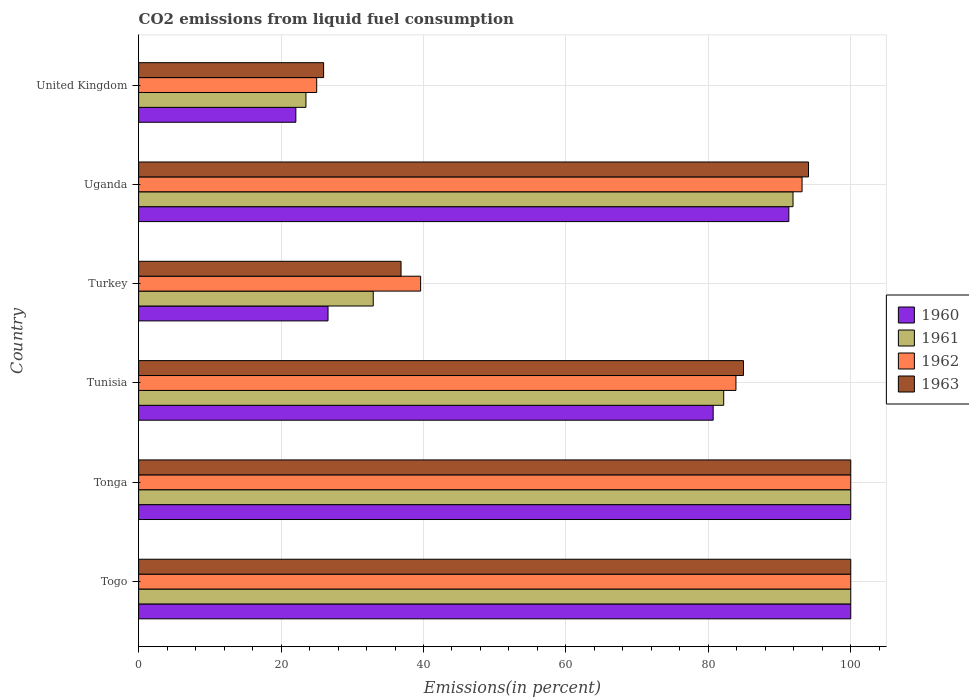How many groups of bars are there?
Give a very brief answer. 6. Are the number of bars on each tick of the Y-axis equal?
Provide a short and direct response. Yes. What is the label of the 5th group of bars from the top?
Provide a short and direct response. Tonga. What is the total CO2 emitted in 1963 in Turkey?
Keep it short and to the point. 36.85. Across all countries, what is the minimum total CO2 emitted in 1960?
Offer a very short reply. 22.08. In which country was the total CO2 emitted in 1962 maximum?
Your answer should be compact. Togo. What is the total total CO2 emitted in 1963 in the graph?
Give a very brief answer. 441.83. What is the difference between the total CO2 emitted in 1961 in Togo and that in Tonga?
Your response must be concise. 0. What is the difference between the total CO2 emitted in 1960 in Tonga and the total CO2 emitted in 1963 in United Kingdom?
Make the answer very short. 74.02. What is the average total CO2 emitted in 1962 per country?
Your answer should be compact. 73.61. What is the difference between the total CO2 emitted in 1960 and total CO2 emitted in 1963 in Tunisia?
Keep it short and to the point. -4.25. What is the ratio of the total CO2 emitted in 1961 in Togo to that in Turkey?
Give a very brief answer. 3.04. Is the difference between the total CO2 emitted in 1960 in Turkey and United Kingdom greater than the difference between the total CO2 emitted in 1963 in Turkey and United Kingdom?
Keep it short and to the point. No. What is the difference between the highest and the lowest total CO2 emitted in 1962?
Provide a short and direct response. 74.99. Is the sum of the total CO2 emitted in 1963 in Tunisia and United Kingdom greater than the maximum total CO2 emitted in 1962 across all countries?
Offer a terse response. Yes. What does the 4th bar from the top in Turkey represents?
Provide a succinct answer. 1960. What does the 3rd bar from the bottom in Uganda represents?
Offer a terse response. 1962. How many bars are there?
Give a very brief answer. 24. Are all the bars in the graph horizontal?
Provide a succinct answer. Yes. How many countries are there in the graph?
Provide a succinct answer. 6. Are the values on the major ticks of X-axis written in scientific E-notation?
Your response must be concise. No. Does the graph contain any zero values?
Offer a terse response. No. How are the legend labels stacked?
Give a very brief answer. Vertical. What is the title of the graph?
Offer a very short reply. CO2 emissions from liquid fuel consumption. Does "1965" appear as one of the legend labels in the graph?
Offer a terse response. No. What is the label or title of the X-axis?
Provide a short and direct response. Emissions(in percent). What is the Emissions(in percent) of 1960 in Togo?
Your answer should be compact. 100. What is the Emissions(in percent) in 1961 in Togo?
Provide a short and direct response. 100. What is the Emissions(in percent) of 1963 in Togo?
Keep it short and to the point. 100. What is the Emissions(in percent) of 1961 in Tonga?
Make the answer very short. 100. What is the Emissions(in percent) of 1963 in Tonga?
Keep it short and to the point. 100. What is the Emissions(in percent) of 1960 in Tunisia?
Your response must be concise. 80.68. What is the Emissions(in percent) in 1961 in Tunisia?
Provide a succinct answer. 82.16. What is the Emissions(in percent) in 1962 in Tunisia?
Your answer should be very brief. 83.88. What is the Emissions(in percent) of 1963 in Tunisia?
Keep it short and to the point. 84.93. What is the Emissions(in percent) in 1960 in Turkey?
Make the answer very short. 26.6. What is the Emissions(in percent) of 1961 in Turkey?
Ensure brevity in your answer.  32.95. What is the Emissions(in percent) in 1962 in Turkey?
Offer a very short reply. 39.6. What is the Emissions(in percent) of 1963 in Turkey?
Make the answer very short. 36.85. What is the Emissions(in percent) in 1960 in Uganda?
Offer a terse response. 91.3. What is the Emissions(in percent) of 1961 in Uganda?
Your response must be concise. 91.89. What is the Emissions(in percent) of 1962 in Uganda?
Provide a succinct answer. 93.16. What is the Emissions(in percent) in 1963 in Uganda?
Keep it short and to the point. 94.07. What is the Emissions(in percent) in 1960 in United Kingdom?
Provide a succinct answer. 22.08. What is the Emissions(in percent) in 1961 in United Kingdom?
Your answer should be compact. 23.5. What is the Emissions(in percent) of 1962 in United Kingdom?
Provide a short and direct response. 25.01. What is the Emissions(in percent) of 1963 in United Kingdom?
Offer a very short reply. 25.98. Across all countries, what is the maximum Emissions(in percent) of 1960?
Keep it short and to the point. 100. Across all countries, what is the maximum Emissions(in percent) in 1961?
Make the answer very short. 100. Across all countries, what is the maximum Emissions(in percent) of 1962?
Your answer should be very brief. 100. Across all countries, what is the minimum Emissions(in percent) in 1960?
Ensure brevity in your answer.  22.08. Across all countries, what is the minimum Emissions(in percent) of 1961?
Your answer should be compact. 23.5. Across all countries, what is the minimum Emissions(in percent) of 1962?
Offer a terse response. 25.01. Across all countries, what is the minimum Emissions(in percent) of 1963?
Ensure brevity in your answer.  25.98. What is the total Emissions(in percent) of 1960 in the graph?
Give a very brief answer. 420.66. What is the total Emissions(in percent) in 1961 in the graph?
Provide a succinct answer. 430.49. What is the total Emissions(in percent) in 1962 in the graph?
Keep it short and to the point. 441.64. What is the total Emissions(in percent) in 1963 in the graph?
Keep it short and to the point. 441.83. What is the difference between the Emissions(in percent) of 1960 in Togo and that in Tonga?
Provide a succinct answer. 0. What is the difference between the Emissions(in percent) of 1961 in Togo and that in Tonga?
Provide a succinct answer. 0. What is the difference between the Emissions(in percent) in 1962 in Togo and that in Tonga?
Give a very brief answer. 0. What is the difference between the Emissions(in percent) in 1963 in Togo and that in Tonga?
Offer a very short reply. 0. What is the difference between the Emissions(in percent) in 1960 in Togo and that in Tunisia?
Ensure brevity in your answer.  19.32. What is the difference between the Emissions(in percent) in 1961 in Togo and that in Tunisia?
Offer a very short reply. 17.84. What is the difference between the Emissions(in percent) of 1962 in Togo and that in Tunisia?
Make the answer very short. 16.12. What is the difference between the Emissions(in percent) in 1963 in Togo and that in Tunisia?
Keep it short and to the point. 15.07. What is the difference between the Emissions(in percent) in 1960 in Togo and that in Turkey?
Provide a short and direct response. 73.4. What is the difference between the Emissions(in percent) in 1961 in Togo and that in Turkey?
Your response must be concise. 67.05. What is the difference between the Emissions(in percent) in 1962 in Togo and that in Turkey?
Your response must be concise. 60.4. What is the difference between the Emissions(in percent) of 1963 in Togo and that in Turkey?
Your answer should be compact. 63.15. What is the difference between the Emissions(in percent) in 1960 in Togo and that in Uganda?
Offer a terse response. 8.7. What is the difference between the Emissions(in percent) of 1961 in Togo and that in Uganda?
Make the answer very short. 8.11. What is the difference between the Emissions(in percent) in 1962 in Togo and that in Uganda?
Offer a very short reply. 6.84. What is the difference between the Emissions(in percent) of 1963 in Togo and that in Uganda?
Offer a very short reply. 5.93. What is the difference between the Emissions(in percent) in 1960 in Togo and that in United Kingdom?
Offer a terse response. 77.92. What is the difference between the Emissions(in percent) in 1961 in Togo and that in United Kingdom?
Ensure brevity in your answer.  76.5. What is the difference between the Emissions(in percent) in 1962 in Togo and that in United Kingdom?
Offer a terse response. 74.99. What is the difference between the Emissions(in percent) of 1963 in Togo and that in United Kingdom?
Provide a short and direct response. 74.02. What is the difference between the Emissions(in percent) in 1960 in Tonga and that in Tunisia?
Your response must be concise. 19.32. What is the difference between the Emissions(in percent) in 1961 in Tonga and that in Tunisia?
Your answer should be compact. 17.84. What is the difference between the Emissions(in percent) of 1962 in Tonga and that in Tunisia?
Your answer should be compact. 16.12. What is the difference between the Emissions(in percent) in 1963 in Tonga and that in Tunisia?
Your response must be concise. 15.07. What is the difference between the Emissions(in percent) in 1960 in Tonga and that in Turkey?
Your response must be concise. 73.4. What is the difference between the Emissions(in percent) of 1961 in Tonga and that in Turkey?
Give a very brief answer. 67.05. What is the difference between the Emissions(in percent) of 1962 in Tonga and that in Turkey?
Provide a short and direct response. 60.4. What is the difference between the Emissions(in percent) of 1963 in Tonga and that in Turkey?
Offer a very short reply. 63.15. What is the difference between the Emissions(in percent) of 1960 in Tonga and that in Uganda?
Your answer should be very brief. 8.7. What is the difference between the Emissions(in percent) of 1961 in Tonga and that in Uganda?
Your response must be concise. 8.11. What is the difference between the Emissions(in percent) in 1962 in Tonga and that in Uganda?
Provide a short and direct response. 6.84. What is the difference between the Emissions(in percent) in 1963 in Tonga and that in Uganda?
Give a very brief answer. 5.93. What is the difference between the Emissions(in percent) of 1960 in Tonga and that in United Kingdom?
Make the answer very short. 77.92. What is the difference between the Emissions(in percent) of 1961 in Tonga and that in United Kingdom?
Make the answer very short. 76.5. What is the difference between the Emissions(in percent) of 1962 in Tonga and that in United Kingdom?
Provide a succinct answer. 74.99. What is the difference between the Emissions(in percent) in 1963 in Tonga and that in United Kingdom?
Offer a very short reply. 74.02. What is the difference between the Emissions(in percent) in 1960 in Tunisia and that in Turkey?
Keep it short and to the point. 54.08. What is the difference between the Emissions(in percent) of 1961 in Tunisia and that in Turkey?
Ensure brevity in your answer.  49.21. What is the difference between the Emissions(in percent) in 1962 in Tunisia and that in Turkey?
Keep it short and to the point. 44.28. What is the difference between the Emissions(in percent) of 1963 in Tunisia and that in Turkey?
Your response must be concise. 48.09. What is the difference between the Emissions(in percent) of 1960 in Tunisia and that in Uganda?
Keep it short and to the point. -10.62. What is the difference between the Emissions(in percent) in 1961 in Tunisia and that in Uganda?
Offer a terse response. -9.73. What is the difference between the Emissions(in percent) of 1962 in Tunisia and that in Uganda?
Your answer should be very brief. -9.28. What is the difference between the Emissions(in percent) of 1963 in Tunisia and that in Uganda?
Make the answer very short. -9.13. What is the difference between the Emissions(in percent) of 1960 in Tunisia and that in United Kingdom?
Your answer should be compact. 58.6. What is the difference between the Emissions(in percent) of 1961 in Tunisia and that in United Kingdom?
Offer a very short reply. 58.66. What is the difference between the Emissions(in percent) of 1962 in Tunisia and that in United Kingdom?
Make the answer very short. 58.87. What is the difference between the Emissions(in percent) of 1963 in Tunisia and that in United Kingdom?
Offer a terse response. 58.96. What is the difference between the Emissions(in percent) of 1960 in Turkey and that in Uganda?
Make the answer very short. -64.71. What is the difference between the Emissions(in percent) in 1961 in Turkey and that in Uganda?
Ensure brevity in your answer.  -58.95. What is the difference between the Emissions(in percent) of 1962 in Turkey and that in Uganda?
Your answer should be compact. -53.56. What is the difference between the Emissions(in percent) of 1963 in Turkey and that in Uganda?
Offer a very short reply. -57.22. What is the difference between the Emissions(in percent) of 1960 in Turkey and that in United Kingdom?
Your answer should be very brief. 4.52. What is the difference between the Emissions(in percent) in 1961 in Turkey and that in United Kingdom?
Your answer should be very brief. 9.45. What is the difference between the Emissions(in percent) in 1962 in Turkey and that in United Kingdom?
Keep it short and to the point. 14.59. What is the difference between the Emissions(in percent) in 1963 in Turkey and that in United Kingdom?
Keep it short and to the point. 10.87. What is the difference between the Emissions(in percent) of 1960 in Uganda and that in United Kingdom?
Your answer should be very brief. 69.23. What is the difference between the Emissions(in percent) of 1961 in Uganda and that in United Kingdom?
Keep it short and to the point. 68.4. What is the difference between the Emissions(in percent) of 1962 in Uganda and that in United Kingdom?
Provide a short and direct response. 68.16. What is the difference between the Emissions(in percent) of 1963 in Uganda and that in United Kingdom?
Offer a terse response. 68.09. What is the difference between the Emissions(in percent) of 1960 in Togo and the Emissions(in percent) of 1962 in Tonga?
Offer a very short reply. 0. What is the difference between the Emissions(in percent) in 1961 in Togo and the Emissions(in percent) in 1962 in Tonga?
Your answer should be compact. 0. What is the difference between the Emissions(in percent) of 1961 in Togo and the Emissions(in percent) of 1963 in Tonga?
Make the answer very short. 0. What is the difference between the Emissions(in percent) of 1962 in Togo and the Emissions(in percent) of 1963 in Tonga?
Ensure brevity in your answer.  0. What is the difference between the Emissions(in percent) of 1960 in Togo and the Emissions(in percent) of 1961 in Tunisia?
Your answer should be very brief. 17.84. What is the difference between the Emissions(in percent) in 1960 in Togo and the Emissions(in percent) in 1962 in Tunisia?
Provide a short and direct response. 16.12. What is the difference between the Emissions(in percent) of 1960 in Togo and the Emissions(in percent) of 1963 in Tunisia?
Give a very brief answer. 15.07. What is the difference between the Emissions(in percent) of 1961 in Togo and the Emissions(in percent) of 1962 in Tunisia?
Your answer should be very brief. 16.12. What is the difference between the Emissions(in percent) in 1961 in Togo and the Emissions(in percent) in 1963 in Tunisia?
Provide a short and direct response. 15.07. What is the difference between the Emissions(in percent) of 1962 in Togo and the Emissions(in percent) of 1963 in Tunisia?
Provide a succinct answer. 15.07. What is the difference between the Emissions(in percent) in 1960 in Togo and the Emissions(in percent) in 1961 in Turkey?
Keep it short and to the point. 67.05. What is the difference between the Emissions(in percent) of 1960 in Togo and the Emissions(in percent) of 1962 in Turkey?
Your response must be concise. 60.4. What is the difference between the Emissions(in percent) in 1960 in Togo and the Emissions(in percent) in 1963 in Turkey?
Provide a short and direct response. 63.15. What is the difference between the Emissions(in percent) in 1961 in Togo and the Emissions(in percent) in 1962 in Turkey?
Your answer should be very brief. 60.4. What is the difference between the Emissions(in percent) of 1961 in Togo and the Emissions(in percent) of 1963 in Turkey?
Ensure brevity in your answer.  63.15. What is the difference between the Emissions(in percent) in 1962 in Togo and the Emissions(in percent) in 1963 in Turkey?
Provide a succinct answer. 63.15. What is the difference between the Emissions(in percent) in 1960 in Togo and the Emissions(in percent) in 1961 in Uganda?
Keep it short and to the point. 8.11. What is the difference between the Emissions(in percent) in 1960 in Togo and the Emissions(in percent) in 1962 in Uganda?
Your response must be concise. 6.84. What is the difference between the Emissions(in percent) in 1960 in Togo and the Emissions(in percent) in 1963 in Uganda?
Offer a very short reply. 5.93. What is the difference between the Emissions(in percent) of 1961 in Togo and the Emissions(in percent) of 1962 in Uganda?
Offer a terse response. 6.84. What is the difference between the Emissions(in percent) of 1961 in Togo and the Emissions(in percent) of 1963 in Uganda?
Your answer should be very brief. 5.93. What is the difference between the Emissions(in percent) of 1962 in Togo and the Emissions(in percent) of 1963 in Uganda?
Ensure brevity in your answer.  5.93. What is the difference between the Emissions(in percent) of 1960 in Togo and the Emissions(in percent) of 1961 in United Kingdom?
Your answer should be compact. 76.5. What is the difference between the Emissions(in percent) in 1960 in Togo and the Emissions(in percent) in 1962 in United Kingdom?
Your answer should be compact. 74.99. What is the difference between the Emissions(in percent) in 1960 in Togo and the Emissions(in percent) in 1963 in United Kingdom?
Offer a very short reply. 74.02. What is the difference between the Emissions(in percent) of 1961 in Togo and the Emissions(in percent) of 1962 in United Kingdom?
Give a very brief answer. 74.99. What is the difference between the Emissions(in percent) in 1961 in Togo and the Emissions(in percent) in 1963 in United Kingdom?
Give a very brief answer. 74.02. What is the difference between the Emissions(in percent) of 1962 in Togo and the Emissions(in percent) of 1963 in United Kingdom?
Offer a very short reply. 74.02. What is the difference between the Emissions(in percent) of 1960 in Tonga and the Emissions(in percent) of 1961 in Tunisia?
Provide a short and direct response. 17.84. What is the difference between the Emissions(in percent) in 1960 in Tonga and the Emissions(in percent) in 1962 in Tunisia?
Keep it short and to the point. 16.12. What is the difference between the Emissions(in percent) in 1960 in Tonga and the Emissions(in percent) in 1963 in Tunisia?
Offer a very short reply. 15.07. What is the difference between the Emissions(in percent) in 1961 in Tonga and the Emissions(in percent) in 1962 in Tunisia?
Your answer should be very brief. 16.12. What is the difference between the Emissions(in percent) of 1961 in Tonga and the Emissions(in percent) of 1963 in Tunisia?
Offer a terse response. 15.07. What is the difference between the Emissions(in percent) in 1962 in Tonga and the Emissions(in percent) in 1963 in Tunisia?
Your answer should be very brief. 15.07. What is the difference between the Emissions(in percent) in 1960 in Tonga and the Emissions(in percent) in 1961 in Turkey?
Provide a succinct answer. 67.05. What is the difference between the Emissions(in percent) of 1960 in Tonga and the Emissions(in percent) of 1962 in Turkey?
Make the answer very short. 60.4. What is the difference between the Emissions(in percent) of 1960 in Tonga and the Emissions(in percent) of 1963 in Turkey?
Offer a terse response. 63.15. What is the difference between the Emissions(in percent) of 1961 in Tonga and the Emissions(in percent) of 1962 in Turkey?
Your response must be concise. 60.4. What is the difference between the Emissions(in percent) in 1961 in Tonga and the Emissions(in percent) in 1963 in Turkey?
Ensure brevity in your answer.  63.15. What is the difference between the Emissions(in percent) of 1962 in Tonga and the Emissions(in percent) of 1963 in Turkey?
Provide a short and direct response. 63.15. What is the difference between the Emissions(in percent) in 1960 in Tonga and the Emissions(in percent) in 1961 in Uganda?
Offer a very short reply. 8.11. What is the difference between the Emissions(in percent) in 1960 in Tonga and the Emissions(in percent) in 1962 in Uganda?
Your answer should be compact. 6.84. What is the difference between the Emissions(in percent) in 1960 in Tonga and the Emissions(in percent) in 1963 in Uganda?
Offer a terse response. 5.93. What is the difference between the Emissions(in percent) in 1961 in Tonga and the Emissions(in percent) in 1962 in Uganda?
Ensure brevity in your answer.  6.84. What is the difference between the Emissions(in percent) in 1961 in Tonga and the Emissions(in percent) in 1963 in Uganda?
Offer a terse response. 5.93. What is the difference between the Emissions(in percent) of 1962 in Tonga and the Emissions(in percent) of 1963 in Uganda?
Provide a succinct answer. 5.93. What is the difference between the Emissions(in percent) in 1960 in Tonga and the Emissions(in percent) in 1961 in United Kingdom?
Offer a terse response. 76.5. What is the difference between the Emissions(in percent) in 1960 in Tonga and the Emissions(in percent) in 1962 in United Kingdom?
Give a very brief answer. 74.99. What is the difference between the Emissions(in percent) in 1960 in Tonga and the Emissions(in percent) in 1963 in United Kingdom?
Offer a very short reply. 74.02. What is the difference between the Emissions(in percent) in 1961 in Tonga and the Emissions(in percent) in 1962 in United Kingdom?
Your answer should be compact. 74.99. What is the difference between the Emissions(in percent) of 1961 in Tonga and the Emissions(in percent) of 1963 in United Kingdom?
Your answer should be compact. 74.02. What is the difference between the Emissions(in percent) in 1962 in Tonga and the Emissions(in percent) in 1963 in United Kingdom?
Offer a terse response. 74.02. What is the difference between the Emissions(in percent) in 1960 in Tunisia and the Emissions(in percent) in 1961 in Turkey?
Offer a terse response. 47.73. What is the difference between the Emissions(in percent) in 1960 in Tunisia and the Emissions(in percent) in 1962 in Turkey?
Give a very brief answer. 41.08. What is the difference between the Emissions(in percent) of 1960 in Tunisia and the Emissions(in percent) of 1963 in Turkey?
Your answer should be compact. 43.83. What is the difference between the Emissions(in percent) of 1961 in Tunisia and the Emissions(in percent) of 1962 in Turkey?
Offer a very short reply. 42.56. What is the difference between the Emissions(in percent) of 1961 in Tunisia and the Emissions(in percent) of 1963 in Turkey?
Provide a succinct answer. 45.31. What is the difference between the Emissions(in percent) in 1962 in Tunisia and the Emissions(in percent) in 1963 in Turkey?
Your answer should be very brief. 47.03. What is the difference between the Emissions(in percent) of 1960 in Tunisia and the Emissions(in percent) of 1961 in Uganda?
Offer a very short reply. -11.21. What is the difference between the Emissions(in percent) of 1960 in Tunisia and the Emissions(in percent) of 1962 in Uganda?
Offer a very short reply. -12.48. What is the difference between the Emissions(in percent) in 1960 in Tunisia and the Emissions(in percent) in 1963 in Uganda?
Keep it short and to the point. -13.39. What is the difference between the Emissions(in percent) of 1961 in Tunisia and the Emissions(in percent) of 1962 in Uganda?
Your response must be concise. -11. What is the difference between the Emissions(in percent) of 1961 in Tunisia and the Emissions(in percent) of 1963 in Uganda?
Your answer should be very brief. -11.91. What is the difference between the Emissions(in percent) in 1962 in Tunisia and the Emissions(in percent) in 1963 in Uganda?
Your response must be concise. -10.19. What is the difference between the Emissions(in percent) of 1960 in Tunisia and the Emissions(in percent) of 1961 in United Kingdom?
Offer a terse response. 57.18. What is the difference between the Emissions(in percent) in 1960 in Tunisia and the Emissions(in percent) in 1962 in United Kingdom?
Offer a terse response. 55.67. What is the difference between the Emissions(in percent) of 1960 in Tunisia and the Emissions(in percent) of 1963 in United Kingdom?
Ensure brevity in your answer.  54.7. What is the difference between the Emissions(in percent) of 1961 in Tunisia and the Emissions(in percent) of 1962 in United Kingdom?
Ensure brevity in your answer.  57.15. What is the difference between the Emissions(in percent) of 1961 in Tunisia and the Emissions(in percent) of 1963 in United Kingdom?
Offer a terse response. 56.18. What is the difference between the Emissions(in percent) in 1962 in Tunisia and the Emissions(in percent) in 1963 in United Kingdom?
Provide a succinct answer. 57.9. What is the difference between the Emissions(in percent) of 1960 in Turkey and the Emissions(in percent) of 1961 in Uganda?
Make the answer very short. -65.3. What is the difference between the Emissions(in percent) of 1960 in Turkey and the Emissions(in percent) of 1962 in Uganda?
Offer a very short reply. -66.57. What is the difference between the Emissions(in percent) of 1960 in Turkey and the Emissions(in percent) of 1963 in Uganda?
Ensure brevity in your answer.  -67.47. What is the difference between the Emissions(in percent) of 1961 in Turkey and the Emissions(in percent) of 1962 in Uganda?
Give a very brief answer. -60.22. What is the difference between the Emissions(in percent) of 1961 in Turkey and the Emissions(in percent) of 1963 in Uganda?
Make the answer very short. -61.12. What is the difference between the Emissions(in percent) in 1962 in Turkey and the Emissions(in percent) in 1963 in Uganda?
Make the answer very short. -54.47. What is the difference between the Emissions(in percent) of 1960 in Turkey and the Emissions(in percent) of 1961 in United Kingdom?
Your response must be concise. 3.1. What is the difference between the Emissions(in percent) in 1960 in Turkey and the Emissions(in percent) in 1962 in United Kingdom?
Give a very brief answer. 1.59. What is the difference between the Emissions(in percent) in 1960 in Turkey and the Emissions(in percent) in 1963 in United Kingdom?
Provide a succinct answer. 0.62. What is the difference between the Emissions(in percent) in 1961 in Turkey and the Emissions(in percent) in 1962 in United Kingdom?
Offer a terse response. 7.94. What is the difference between the Emissions(in percent) of 1961 in Turkey and the Emissions(in percent) of 1963 in United Kingdom?
Keep it short and to the point. 6.97. What is the difference between the Emissions(in percent) in 1962 in Turkey and the Emissions(in percent) in 1963 in United Kingdom?
Make the answer very short. 13.62. What is the difference between the Emissions(in percent) of 1960 in Uganda and the Emissions(in percent) of 1961 in United Kingdom?
Offer a very short reply. 67.81. What is the difference between the Emissions(in percent) in 1960 in Uganda and the Emissions(in percent) in 1962 in United Kingdom?
Ensure brevity in your answer.  66.3. What is the difference between the Emissions(in percent) in 1960 in Uganda and the Emissions(in percent) in 1963 in United Kingdom?
Your response must be concise. 65.33. What is the difference between the Emissions(in percent) in 1961 in Uganda and the Emissions(in percent) in 1962 in United Kingdom?
Your answer should be compact. 66.89. What is the difference between the Emissions(in percent) of 1961 in Uganda and the Emissions(in percent) of 1963 in United Kingdom?
Offer a terse response. 65.91. What is the difference between the Emissions(in percent) in 1962 in Uganda and the Emissions(in percent) in 1963 in United Kingdom?
Your response must be concise. 67.18. What is the average Emissions(in percent) in 1960 per country?
Your answer should be very brief. 70.11. What is the average Emissions(in percent) in 1961 per country?
Give a very brief answer. 71.75. What is the average Emissions(in percent) of 1962 per country?
Offer a terse response. 73.61. What is the average Emissions(in percent) of 1963 per country?
Ensure brevity in your answer.  73.64. What is the difference between the Emissions(in percent) of 1960 and Emissions(in percent) of 1963 in Togo?
Keep it short and to the point. 0. What is the difference between the Emissions(in percent) in 1961 and Emissions(in percent) in 1962 in Togo?
Make the answer very short. 0. What is the difference between the Emissions(in percent) of 1961 and Emissions(in percent) of 1963 in Togo?
Offer a very short reply. 0. What is the difference between the Emissions(in percent) of 1960 and Emissions(in percent) of 1961 in Tonga?
Give a very brief answer. 0. What is the difference between the Emissions(in percent) of 1960 and Emissions(in percent) of 1963 in Tonga?
Your response must be concise. 0. What is the difference between the Emissions(in percent) in 1961 and Emissions(in percent) in 1962 in Tonga?
Provide a succinct answer. 0. What is the difference between the Emissions(in percent) in 1960 and Emissions(in percent) in 1961 in Tunisia?
Offer a very short reply. -1.48. What is the difference between the Emissions(in percent) in 1960 and Emissions(in percent) in 1962 in Tunisia?
Keep it short and to the point. -3.2. What is the difference between the Emissions(in percent) in 1960 and Emissions(in percent) in 1963 in Tunisia?
Keep it short and to the point. -4.25. What is the difference between the Emissions(in percent) of 1961 and Emissions(in percent) of 1962 in Tunisia?
Provide a succinct answer. -1.72. What is the difference between the Emissions(in percent) of 1961 and Emissions(in percent) of 1963 in Tunisia?
Offer a terse response. -2.78. What is the difference between the Emissions(in percent) in 1962 and Emissions(in percent) in 1963 in Tunisia?
Offer a very short reply. -1.06. What is the difference between the Emissions(in percent) in 1960 and Emissions(in percent) in 1961 in Turkey?
Give a very brief answer. -6.35. What is the difference between the Emissions(in percent) of 1960 and Emissions(in percent) of 1962 in Turkey?
Ensure brevity in your answer.  -13. What is the difference between the Emissions(in percent) of 1960 and Emissions(in percent) of 1963 in Turkey?
Give a very brief answer. -10.25. What is the difference between the Emissions(in percent) of 1961 and Emissions(in percent) of 1962 in Turkey?
Make the answer very short. -6.65. What is the difference between the Emissions(in percent) of 1961 and Emissions(in percent) of 1963 in Turkey?
Ensure brevity in your answer.  -3.9. What is the difference between the Emissions(in percent) in 1962 and Emissions(in percent) in 1963 in Turkey?
Ensure brevity in your answer.  2.75. What is the difference between the Emissions(in percent) in 1960 and Emissions(in percent) in 1961 in Uganda?
Provide a succinct answer. -0.59. What is the difference between the Emissions(in percent) in 1960 and Emissions(in percent) in 1962 in Uganda?
Keep it short and to the point. -1.86. What is the difference between the Emissions(in percent) of 1960 and Emissions(in percent) of 1963 in Uganda?
Ensure brevity in your answer.  -2.76. What is the difference between the Emissions(in percent) in 1961 and Emissions(in percent) in 1962 in Uganda?
Offer a terse response. -1.27. What is the difference between the Emissions(in percent) of 1961 and Emissions(in percent) of 1963 in Uganda?
Offer a terse response. -2.18. What is the difference between the Emissions(in percent) of 1962 and Emissions(in percent) of 1963 in Uganda?
Your response must be concise. -0.91. What is the difference between the Emissions(in percent) of 1960 and Emissions(in percent) of 1961 in United Kingdom?
Offer a very short reply. -1.42. What is the difference between the Emissions(in percent) of 1960 and Emissions(in percent) of 1962 in United Kingdom?
Your answer should be compact. -2.93. What is the difference between the Emissions(in percent) of 1960 and Emissions(in percent) of 1963 in United Kingdom?
Give a very brief answer. -3.9. What is the difference between the Emissions(in percent) of 1961 and Emissions(in percent) of 1962 in United Kingdom?
Your answer should be very brief. -1.51. What is the difference between the Emissions(in percent) in 1961 and Emissions(in percent) in 1963 in United Kingdom?
Ensure brevity in your answer.  -2.48. What is the difference between the Emissions(in percent) in 1962 and Emissions(in percent) in 1963 in United Kingdom?
Give a very brief answer. -0.97. What is the ratio of the Emissions(in percent) of 1963 in Togo to that in Tonga?
Keep it short and to the point. 1. What is the ratio of the Emissions(in percent) of 1960 in Togo to that in Tunisia?
Keep it short and to the point. 1.24. What is the ratio of the Emissions(in percent) of 1961 in Togo to that in Tunisia?
Provide a succinct answer. 1.22. What is the ratio of the Emissions(in percent) in 1962 in Togo to that in Tunisia?
Offer a very short reply. 1.19. What is the ratio of the Emissions(in percent) in 1963 in Togo to that in Tunisia?
Ensure brevity in your answer.  1.18. What is the ratio of the Emissions(in percent) in 1960 in Togo to that in Turkey?
Offer a very short reply. 3.76. What is the ratio of the Emissions(in percent) in 1961 in Togo to that in Turkey?
Make the answer very short. 3.04. What is the ratio of the Emissions(in percent) of 1962 in Togo to that in Turkey?
Make the answer very short. 2.53. What is the ratio of the Emissions(in percent) in 1963 in Togo to that in Turkey?
Ensure brevity in your answer.  2.71. What is the ratio of the Emissions(in percent) of 1960 in Togo to that in Uganda?
Provide a short and direct response. 1.1. What is the ratio of the Emissions(in percent) in 1961 in Togo to that in Uganda?
Your answer should be compact. 1.09. What is the ratio of the Emissions(in percent) of 1962 in Togo to that in Uganda?
Your answer should be very brief. 1.07. What is the ratio of the Emissions(in percent) in 1963 in Togo to that in Uganda?
Your answer should be very brief. 1.06. What is the ratio of the Emissions(in percent) in 1960 in Togo to that in United Kingdom?
Provide a short and direct response. 4.53. What is the ratio of the Emissions(in percent) in 1961 in Togo to that in United Kingdom?
Keep it short and to the point. 4.26. What is the ratio of the Emissions(in percent) of 1962 in Togo to that in United Kingdom?
Give a very brief answer. 4. What is the ratio of the Emissions(in percent) in 1963 in Togo to that in United Kingdom?
Your answer should be very brief. 3.85. What is the ratio of the Emissions(in percent) of 1960 in Tonga to that in Tunisia?
Provide a succinct answer. 1.24. What is the ratio of the Emissions(in percent) of 1961 in Tonga to that in Tunisia?
Offer a very short reply. 1.22. What is the ratio of the Emissions(in percent) in 1962 in Tonga to that in Tunisia?
Provide a short and direct response. 1.19. What is the ratio of the Emissions(in percent) in 1963 in Tonga to that in Tunisia?
Your answer should be very brief. 1.18. What is the ratio of the Emissions(in percent) in 1960 in Tonga to that in Turkey?
Ensure brevity in your answer.  3.76. What is the ratio of the Emissions(in percent) in 1961 in Tonga to that in Turkey?
Make the answer very short. 3.04. What is the ratio of the Emissions(in percent) in 1962 in Tonga to that in Turkey?
Give a very brief answer. 2.53. What is the ratio of the Emissions(in percent) of 1963 in Tonga to that in Turkey?
Provide a succinct answer. 2.71. What is the ratio of the Emissions(in percent) of 1960 in Tonga to that in Uganda?
Ensure brevity in your answer.  1.1. What is the ratio of the Emissions(in percent) in 1961 in Tonga to that in Uganda?
Ensure brevity in your answer.  1.09. What is the ratio of the Emissions(in percent) of 1962 in Tonga to that in Uganda?
Your answer should be very brief. 1.07. What is the ratio of the Emissions(in percent) of 1963 in Tonga to that in Uganda?
Offer a terse response. 1.06. What is the ratio of the Emissions(in percent) in 1960 in Tonga to that in United Kingdom?
Offer a very short reply. 4.53. What is the ratio of the Emissions(in percent) of 1961 in Tonga to that in United Kingdom?
Your response must be concise. 4.26. What is the ratio of the Emissions(in percent) of 1962 in Tonga to that in United Kingdom?
Ensure brevity in your answer.  4. What is the ratio of the Emissions(in percent) of 1963 in Tonga to that in United Kingdom?
Your answer should be very brief. 3.85. What is the ratio of the Emissions(in percent) of 1960 in Tunisia to that in Turkey?
Keep it short and to the point. 3.03. What is the ratio of the Emissions(in percent) in 1961 in Tunisia to that in Turkey?
Your answer should be compact. 2.49. What is the ratio of the Emissions(in percent) of 1962 in Tunisia to that in Turkey?
Your response must be concise. 2.12. What is the ratio of the Emissions(in percent) of 1963 in Tunisia to that in Turkey?
Your answer should be compact. 2.3. What is the ratio of the Emissions(in percent) in 1960 in Tunisia to that in Uganda?
Your answer should be very brief. 0.88. What is the ratio of the Emissions(in percent) in 1961 in Tunisia to that in Uganda?
Keep it short and to the point. 0.89. What is the ratio of the Emissions(in percent) of 1962 in Tunisia to that in Uganda?
Offer a terse response. 0.9. What is the ratio of the Emissions(in percent) in 1963 in Tunisia to that in Uganda?
Keep it short and to the point. 0.9. What is the ratio of the Emissions(in percent) of 1960 in Tunisia to that in United Kingdom?
Ensure brevity in your answer.  3.65. What is the ratio of the Emissions(in percent) in 1961 in Tunisia to that in United Kingdom?
Ensure brevity in your answer.  3.5. What is the ratio of the Emissions(in percent) in 1962 in Tunisia to that in United Kingdom?
Provide a short and direct response. 3.35. What is the ratio of the Emissions(in percent) in 1963 in Tunisia to that in United Kingdom?
Provide a short and direct response. 3.27. What is the ratio of the Emissions(in percent) of 1960 in Turkey to that in Uganda?
Make the answer very short. 0.29. What is the ratio of the Emissions(in percent) in 1961 in Turkey to that in Uganda?
Ensure brevity in your answer.  0.36. What is the ratio of the Emissions(in percent) in 1962 in Turkey to that in Uganda?
Provide a short and direct response. 0.43. What is the ratio of the Emissions(in percent) of 1963 in Turkey to that in Uganda?
Give a very brief answer. 0.39. What is the ratio of the Emissions(in percent) of 1960 in Turkey to that in United Kingdom?
Your response must be concise. 1.2. What is the ratio of the Emissions(in percent) in 1961 in Turkey to that in United Kingdom?
Provide a short and direct response. 1.4. What is the ratio of the Emissions(in percent) of 1962 in Turkey to that in United Kingdom?
Make the answer very short. 1.58. What is the ratio of the Emissions(in percent) of 1963 in Turkey to that in United Kingdom?
Your response must be concise. 1.42. What is the ratio of the Emissions(in percent) of 1960 in Uganda to that in United Kingdom?
Make the answer very short. 4.14. What is the ratio of the Emissions(in percent) of 1961 in Uganda to that in United Kingdom?
Ensure brevity in your answer.  3.91. What is the ratio of the Emissions(in percent) in 1962 in Uganda to that in United Kingdom?
Your response must be concise. 3.73. What is the ratio of the Emissions(in percent) in 1963 in Uganda to that in United Kingdom?
Your response must be concise. 3.62. What is the difference between the highest and the second highest Emissions(in percent) in 1960?
Offer a very short reply. 0. What is the difference between the highest and the second highest Emissions(in percent) in 1962?
Make the answer very short. 0. What is the difference between the highest and the second highest Emissions(in percent) in 1963?
Offer a terse response. 0. What is the difference between the highest and the lowest Emissions(in percent) of 1960?
Keep it short and to the point. 77.92. What is the difference between the highest and the lowest Emissions(in percent) in 1961?
Ensure brevity in your answer.  76.5. What is the difference between the highest and the lowest Emissions(in percent) in 1962?
Your answer should be very brief. 74.99. What is the difference between the highest and the lowest Emissions(in percent) in 1963?
Ensure brevity in your answer.  74.02. 